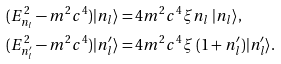Convert formula to latex. <formula><loc_0><loc_0><loc_500><loc_500>& ( E _ { n _ { l } } ^ { 2 } - m ^ { 2 } c ^ { 4 } ) | n _ { l } \rangle = 4 m ^ { 2 } c ^ { 4 } \xi n _ { l } \ | n _ { l } \rangle , \\ & ( E _ { n _ { l } ^ { \prime } } ^ { 2 } - m ^ { 2 } c ^ { 4 } ) | n _ { l } ^ { \prime } \rangle = 4 m ^ { 2 } c ^ { 4 } \xi \ ( 1 + n _ { l } ^ { \prime } ) | n _ { l } ^ { \prime } \rangle . \\</formula> 